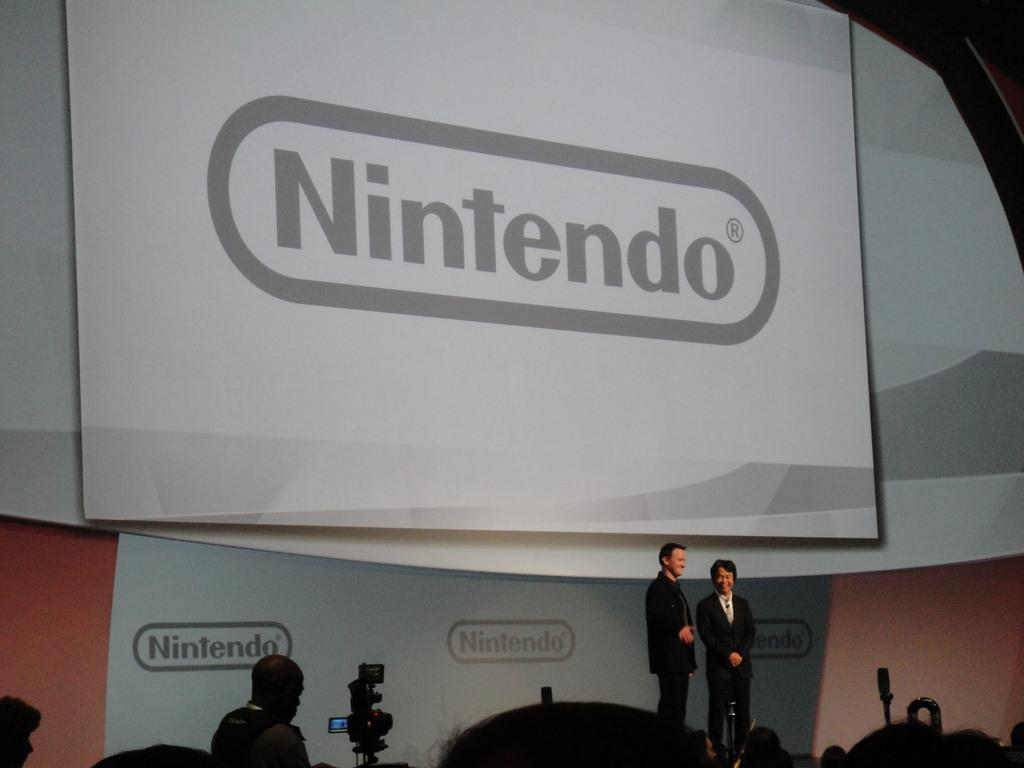How many people are in the image? There are people in the image. Can you describe the person with a camera? A person is present with a camera. What are the two people at the back wearing? The two people at the back are wearing suits. What is written on the banner in the image? The banner has the word "Nintendo" written on it. How many firemen are present in the image? There are no firemen present in the image. What type of car can be seen in the background of the image? There is no car visible in the image. 